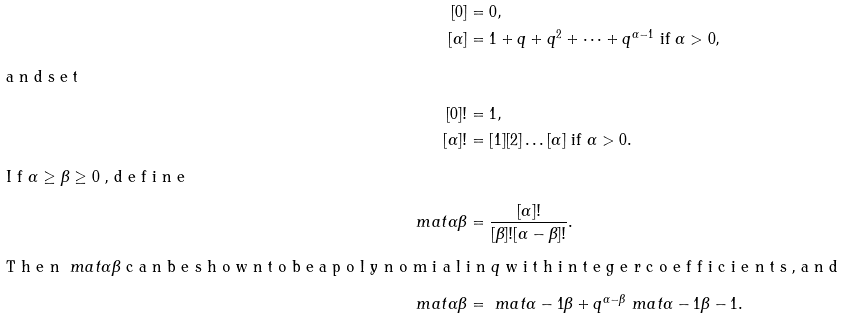Convert formula to latex. <formula><loc_0><loc_0><loc_500><loc_500>[ 0 ] & = 0 , \\ [ \alpha ] & = 1 + q + q ^ { 2 } + \dots + q ^ { \alpha - 1 } \text { if } \alpha > 0 , \\ \intertext { a n d s e t } [ 0 ] ! & = 1 , \\ [ \alpha ] ! & = [ 1 ] [ 2 ] \dots [ \alpha ] \text { if } \alpha > 0 . \\ \intertext { I f $ \alpha \geq \beta \geq 0 $ , d e f i n e } \ m a t { \alpha } { \beta } & = \frac { [ \alpha ] ! } { [ \beta ] ! [ \alpha - \beta ] ! } . \\ \intertext { T h e n $ \ m a t { \alpha } { \beta } $ c a n b e s h o w n t o b e a p o l y n o m i a l i n $ q $ w i t h i n t e g e r c o e f f i c i e n t s , a n d } \ m a t { \alpha } { \beta } & = \ m a t { \alpha - 1 } { \beta } + q ^ { \alpha - \beta } \ m a t { \alpha - 1 } { \beta - 1 } .</formula> 